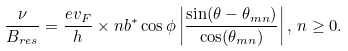Convert formula to latex. <formula><loc_0><loc_0><loc_500><loc_500>\frac { \nu } { B _ { r e s } } = \frac { e v _ { F } } { h } \times n b ^ { * } \cos \phi \left | \frac { \sin ( \theta - \theta _ { m n } ) } { \cos ( \theta _ { m n } ) } \right | , \, n \geq 0 .</formula> 